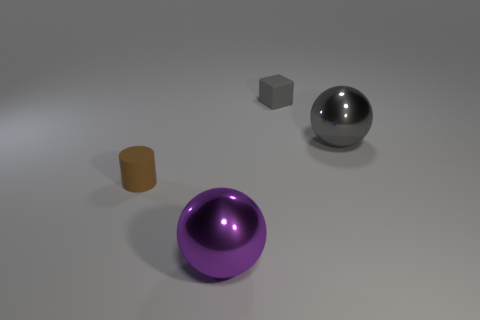Add 1 big purple balls. How many objects exist? 5 Subtract all purple balls. How many balls are left? 1 Subtract all brown cylinders. How many purple spheres are left? 1 Subtract all blue metallic cubes. Subtract all small rubber blocks. How many objects are left? 3 Add 4 large shiny balls. How many large shiny balls are left? 6 Add 1 blue objects. How many blue objects exist? 1 Subtract 0 green balls. How many objects are left? 4 Subtract all cylinders. How many objects are left? 3 Subtract 2 spheres. How many spheres are left? 0 Subtract all brown blocks. Subtract all gray balls. How many blocks are left? 1 